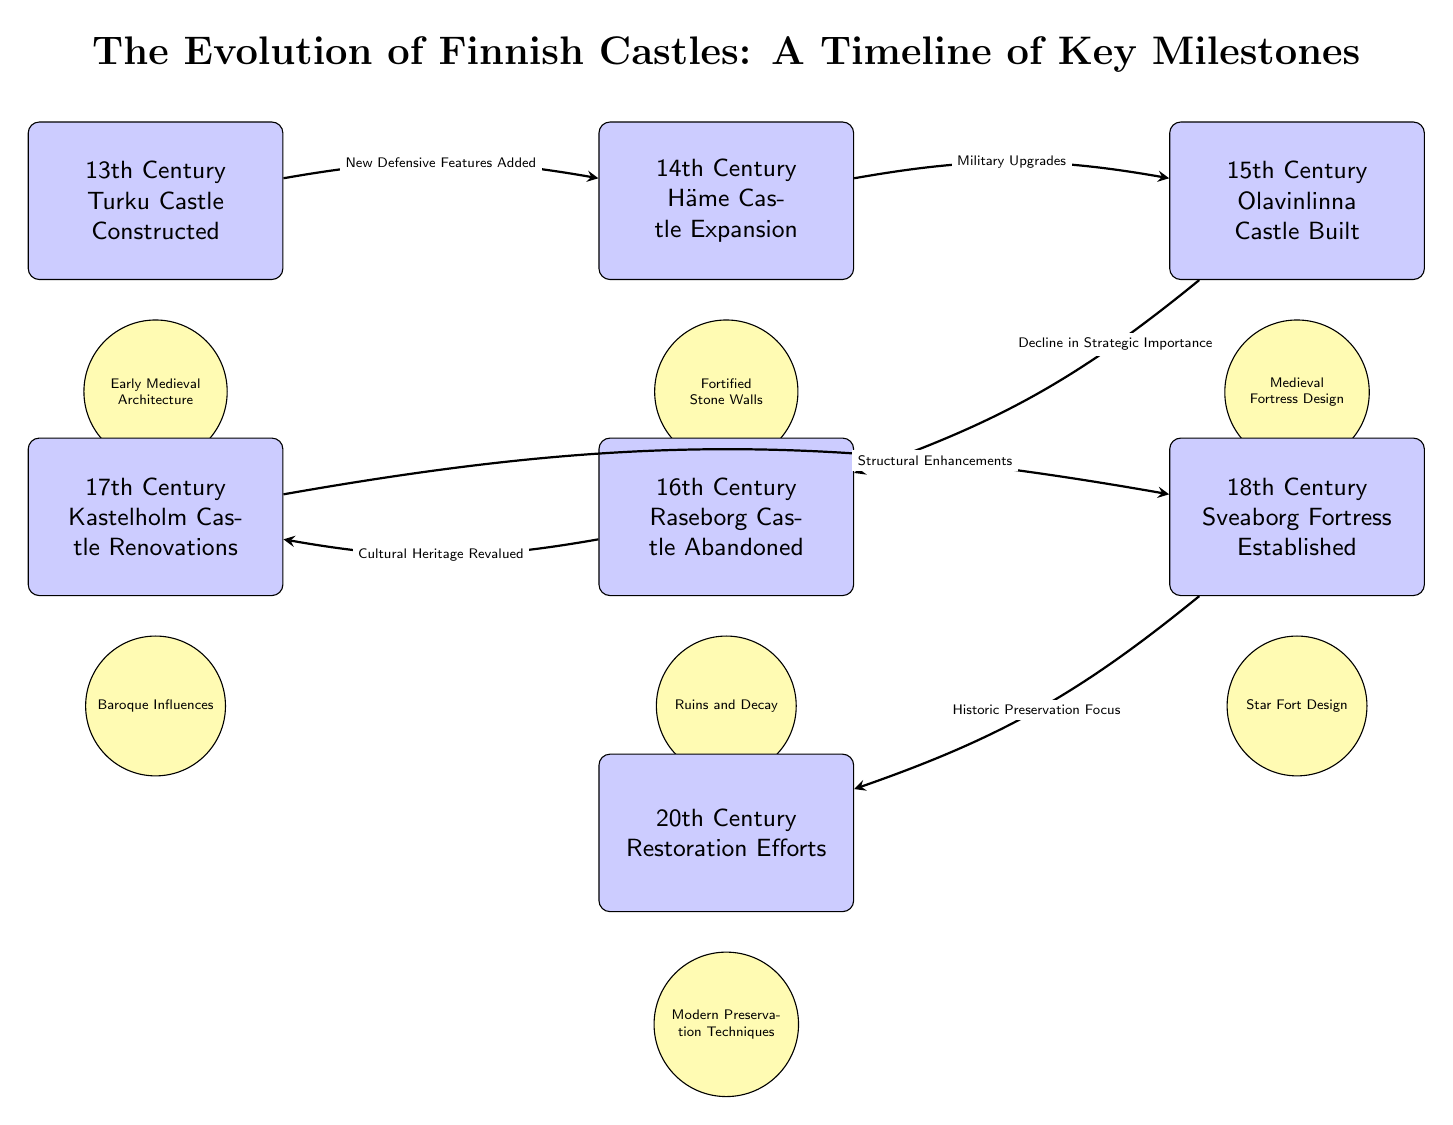What event marks the construction of Turku Castle? The diagram shows that Turku Castle was constructed in the 13th Century, identifying it as the first event on the timeline.
Answer: 13th Century Turku Castle Constructed Which castle experienced abandonment in the 16th century? According to the diagram, Raseborg Castle is noted as abandoned during the 16th Century, highlighted as a significant milestone.
Answer: Raseborg Castle Abandoned How many architectural styles are illustrated in the diagram? By examining the illustrations below each event, we can identify that there are three distinct architectural styles represented: Early Medieval Architecture, Baroque Influences, and Star Fort Design, among others. Counting these gives us a total of six styles.
Answer: Six What is the primary reason cited for the decline in strategic importance of Olavinlinna Castle? The diagram indicates that the decline in strategic importance is attributed to historical context, aligning it with the transition from 15th to 16th centuries in the timeline.
Answer: Decline in Strategic Importance What major shift in preservation focus occurred in the 20th century? The diagram points out that in the 20th Century, efforts in historic preservation were emphasized, marking a significant change in the approach to maintaining these castles.
Answer: Historic Preservation Focus What architectural feature was added after the construction of Turku Castle? The relationship depicted in the diagram shows that new defensive features were added after the construction of Turku Castle, leading to the expansion at Häme Castle in the 14th Century.
Answer: New Defensive Features Added Which castle was involved in renovations during the 17th century? The diagram states that Kastelholm Castle underwent renovations in the 17th Century, making it a focal point for that period's architectural changes.
Answer: Kastelholm Castle Renovations What influenced the design changes in Sveaborg Fortress? The diagram illustrates that the design of Sveaborg Fortress was influenced by the star fort design, marking a new trend in fortification style during the 18th Century.
Answer: Star Fort Design 